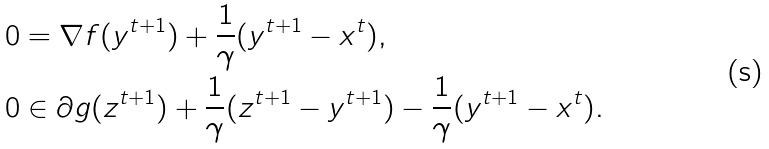<formula> <loc_0><loc_0><loc_500><loc_500>0 & = \nabla f ( y ^ { t + 1 } ) + \frac { 1 } { \gamma } ( y ^ { t + 1 } - x ^ { t } ) , \\ 0 & \in \partial g ( z ^ { t + 1 } ) + \frac { 1 } { \gamma } ( z ^ { t + 1 } - y ^ { t + 1 } ) - \frac { 1 } { \gamma } ( y ^ { t + 1 } - x ^ { t } ) .</formula> 